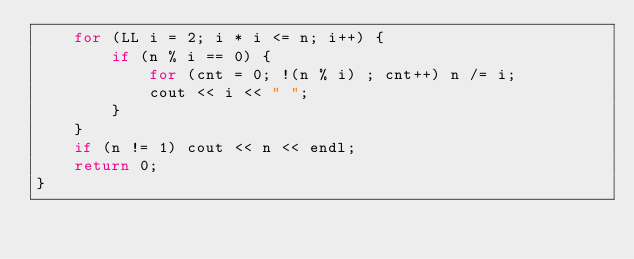<code> <loc_0><loc_0><loc_500><loc_500><_C++_>	for (LL i = 2; i * i <= n; i++) {
		if (n % i == 0) {
			for (cnt = 0; !(n % i) ; cnt++) n /= i;
			cout << i << " ";
		}
	}
	if (n != 1) cout << n << endl;
	return 0;
}
</code> 